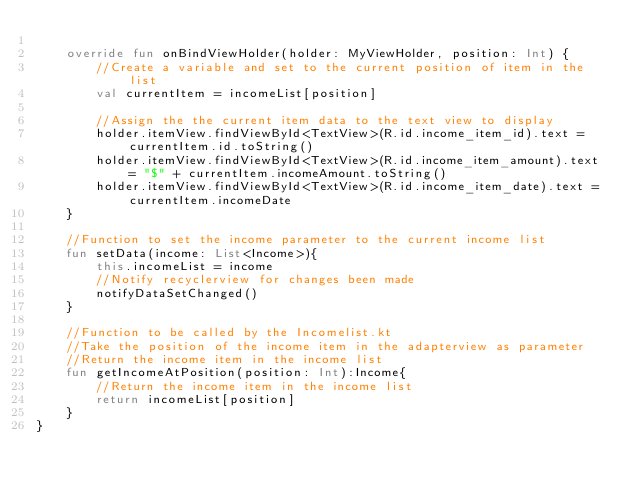<code> <loc_0><loc_0><loc_500><loc_500><_Kotlin_>
    override fun onBindViewHolder(holder: MyViewHolder, position: Int) {
        //Create a variable and set to the current position of item in the list
        val currentItem = incomeList[position]

        //Assign the the current item data to the text view to display
        holder.itemView.findViewById<TextView>(R.id.income_item_id).text = currentItem.id.toString()
        holder.itemView.findViewById<TextView>(R.id.income_item_amount).text = "$" + currentItem.incomeAmount.toString()
        holder.itemView.findViewById<TextView>(R.id.income_item_date).text = currentItem.incomeDate
    }

    //Function to set the income parameter to the current income list
    fun setData(income: List<Income>){
        this.incomeList = income
        //Notify recyclerview for changes been made
        notifyDataSetChanged()
    }

    //Function to be called by the Incomelist.kt
    //Take the position of the income item in the adapterview as parameter
    //Return the income item in the income list
    fun getIncomeAtPosition(position: Int):Income{
        //Return the income item in the income list
        return incomeList[position]
    }
}</code> 